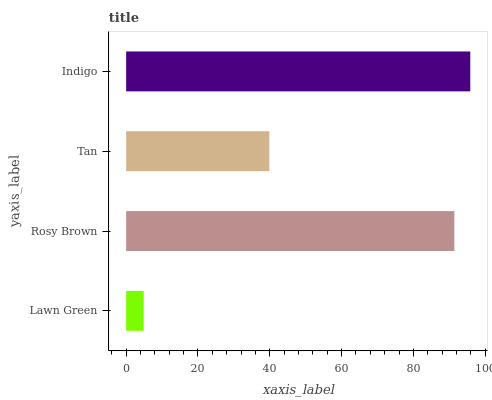Is Lawn Green the minimum?
Answer yes or no. Yes. Is Indigo the maximum?
Answer yes or no. Yes. Is Rosy Brown the minimum?
Answer yes or no. No. Is Rosy Brown the maximum?
Answer yes or no. No. Is Rosy Brown greater than Lawn Green?
Answer yes or no. Yes. Is Lawn Green less than Rosy Brown?
Answer yes or no. Yes. Is Lawn Green greater than Rosy Brown?
Answer yes or no. No. Is Rosy Brown less than Lawn Green?
Answer yes or no. No. Is Rosy Brown the high median?
Answer yes or no. Yes. Is Tan the low median?
Answer yes or no. Yes. Is Indigo the high median?
Answer yes or no. No. Is Lawn Green the low median?
Answer yes or no. No. 